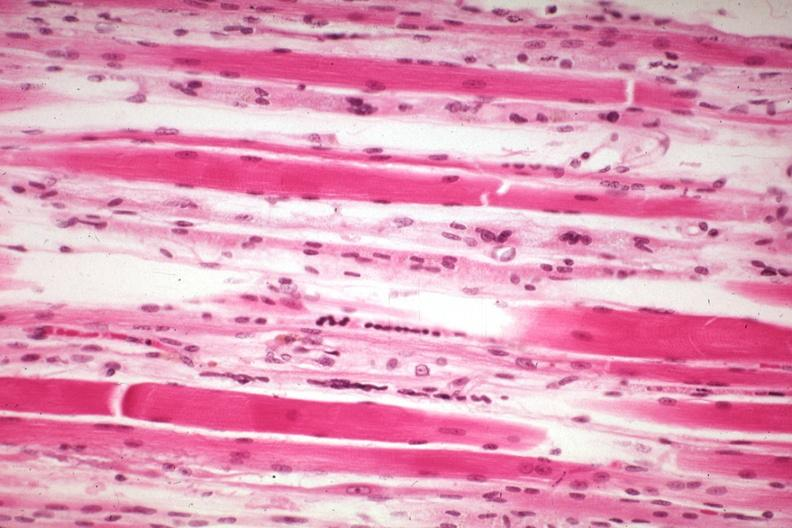what is present?
Answer the question using a single word or phrase. Muscle 